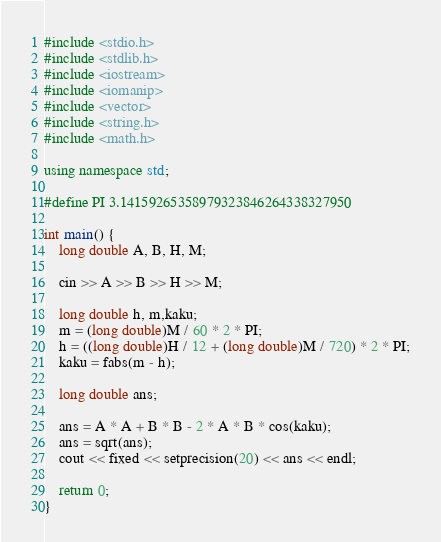Convert code to text. <code><loc_0><loc_0><loc_500><loc_500><_C++_>#include <stdio.h>
#include <stdlib.h>
#include <iostream>
#include <iomanip>
#include <vector>
#include <string.h>
#include <math.h>

using namespace std;

#define PI 3.14159265358979323846264338327950

int main() {
	long double A, B, H, M;

	cin >> A >> B >> H >> M;

	long double h, m,kaku;
	m = (long double)M / 60 * 2 * PI;
	h = ((long double)H / 12 + (long double)M / 720) * 2 * PI;
	kaku = fabs(m - h);

	long double ans;

	ans = A * A + B * B - 2 * A * B * cos(kaku);
	ans = sqrt(ans);
	cout << fixed << setprecision(20) << ans << endl;

	return 0;
}</code> 